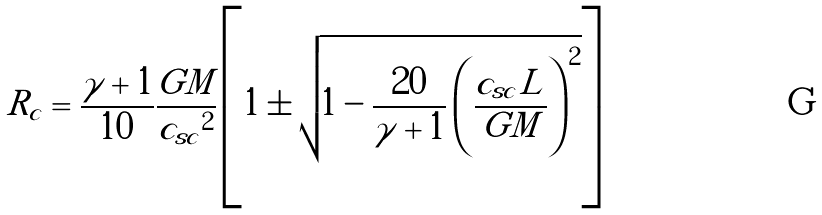Convert formula to latex. <formula><loc_0><loc_0><loc_500><loc_500>R _ { c } = \frac { \gamma + 1 } { 1 0 } \frac { G M } { { c _ { s c } } ^ { 2 } } \left [ 1 \pm \sqrt { 1 - \frac { 2 0 } { \gamma + 1 } \left ( \frac { c _ { s c } L } { G M } \right ) ^ { 2 } } \right ]</formula> 